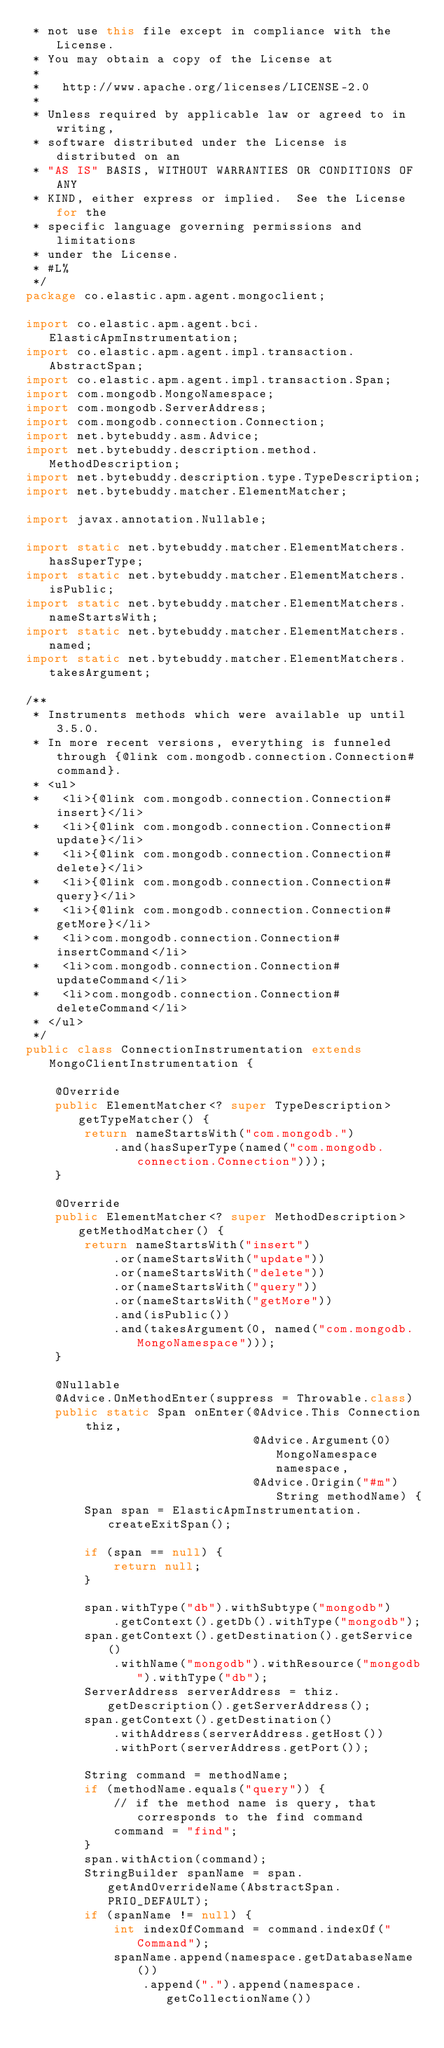<code> <loc_0><loc_0><loc_500><loc_500><_Java_> * not use this file except in compliance with the License.
 * You may obtain a copy of the License at
 * 
 *   http://www.apache.org/licenses/LICENSE-2.0
 * 
 * Unless required by applicable law or agreed to in writing,
 * software distributed under the License is distributed on an
 * "AS IS" BASIS, WITHOUT WARRANTIES OR CONDITIONS OF ANY
 * KIND, either express or implied.  See the License for the
 * specific language governing permissions and limitations
 * under the License.
 * #L%
 */
package co.elastic.apm.agent.mongoclient;

import co.elastic.apm.agent.bci.ElasticApmInstrumentation;
import co.elastic.apm.agent.impl.transaction.AbstractSpan;
import co.elastic.apm.agent.impl.transaction.Span;
import com.mongodb.MongoNamespace;
import com.mongodb.ServerAddress;
import com.mongodb.connection.Connection;
import net.bytebuddy.asm.Advice;
import net.bytebuddy.description.method.MethodDescription;
import net.bytebuddy.description.type.TypeDescription;
import net.bytebuddy.matcher.ElementMatcher;

import javax.annotation.Nullable;

import static net.bytebuddy.matcher.ElementMatchers.hasSuperType;
import static net.bytebuddy.matcher.ElementMatchers.isPublic;
import static net.bytebuddy.matcher.ElementMatchers.nameStartsWith;
import static net.bytebuddy.matcher.ElementMatchers.named;
import static net.bytebuddy.matcher.ElementMatchers.takesArgument;

/**
 * Instruments methods which were available up until 3.5.0.
 * In more recent versions, everything is funneled through {@link com.mongodb.connection.Connection#command}.
 * <ul>
 *   <li>{@link com.mongodb.connection.Connection#insert}</li>
 *   <li>{@link com.mongodb.connection.Connection#update}</li>
 *   <li>{@link com.mongodb.connection.Connection#delete}</li>
 *   <li>{@link com.mongodb.connection.Connection#query}</li>
 *   <li>{@link com.mongodb.connection.Connection#getMore}</li>
 *   <li>com.mongodb.connection.Connection#insertCommand</li>
 *   <li>com.mongodb.connection.Connection#updateCommand</li>
 *   <li>com.mongodb.connection.Connection#deleteCommand</li>
 * </ul>
 */
public class ConnectionInstrumentation extends MongoClientInstrumentation {

    @Override
    public ElementMatcher<? super TypeDescription> getTypeMatcher() {
        return nameStartsWith("com.mongodb.")
            .and(hasSuperType(named("com.mongodb.connection.Connection")));
    }

    @Override
    public ElementMatcher<? super MethodDescription> getMethodMatcher() {
        return nameStartsWith("insert")
            .or(nameStartsWith("update"))
            .or(nameStartsWith("delete"))
            .or(nameStartsWith("query"))
            .or(nameStartsWith("getMore"))
            .and(isPublic())
            .and(takesArgument(0, named("com.mongodb.MongoNamespace")));
    }

    @Nullable
    @Advice.OnMethodEnter(suppress = Throwable.class)
    public static Span onEnter(@Advice.This Connection thiz,
                               @Advice.Argument(0) MongoNamespace namespace,
                               @Advice.Origin("#m") String methodName) {
        Span span = ElasticApmInstrumentation.createExitSpan();

        if (span == null) {
            return null;
        }

        span.withType("db").withSubtype("mongodb")
            .getContext().getDb().withType("mongodb");
        span.getContext().getDestination().getService()
            .withName("mongodb").withResource("mongodb").withType("db");
        ServerAddress serverAddress = thiz.getDescription().getServerAddress();
        span.getContext().getDestination()
            .withAddress(serverAddress.getHost())
            .withPort(serverAddress.getPort());

        String command = methodName;
        if (methodName.equals("query")) {
            // if the method name is query, that corresponds to the find command
            command = "find";
        }
        span.withAction(command);
        StringBuilder spanName = span.getAndOverrideName(AbstractSpan.PRIO_DEFAULT);
        if (spanName != null) {
            int indexOfCommand = command.indexOf("Command");
            spanName.append(namespace.getDatabaseName())
                .append(".").append(namespace.getCollectionName())</code> 